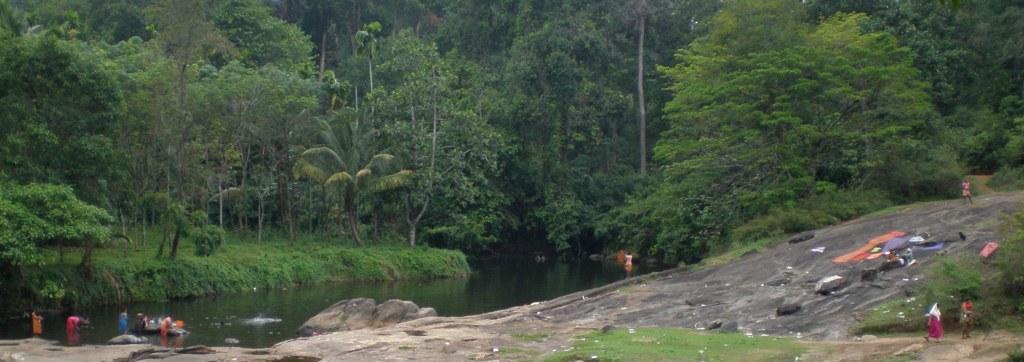How would you summarize this image in a sentence or two? This is an outside view. On the left side there is a river and few people are standing in the water. On the right side there is a rock where few clothes are placed and few people are standing. At the bottom of the image I can see the grass. In the background there are many trees. 